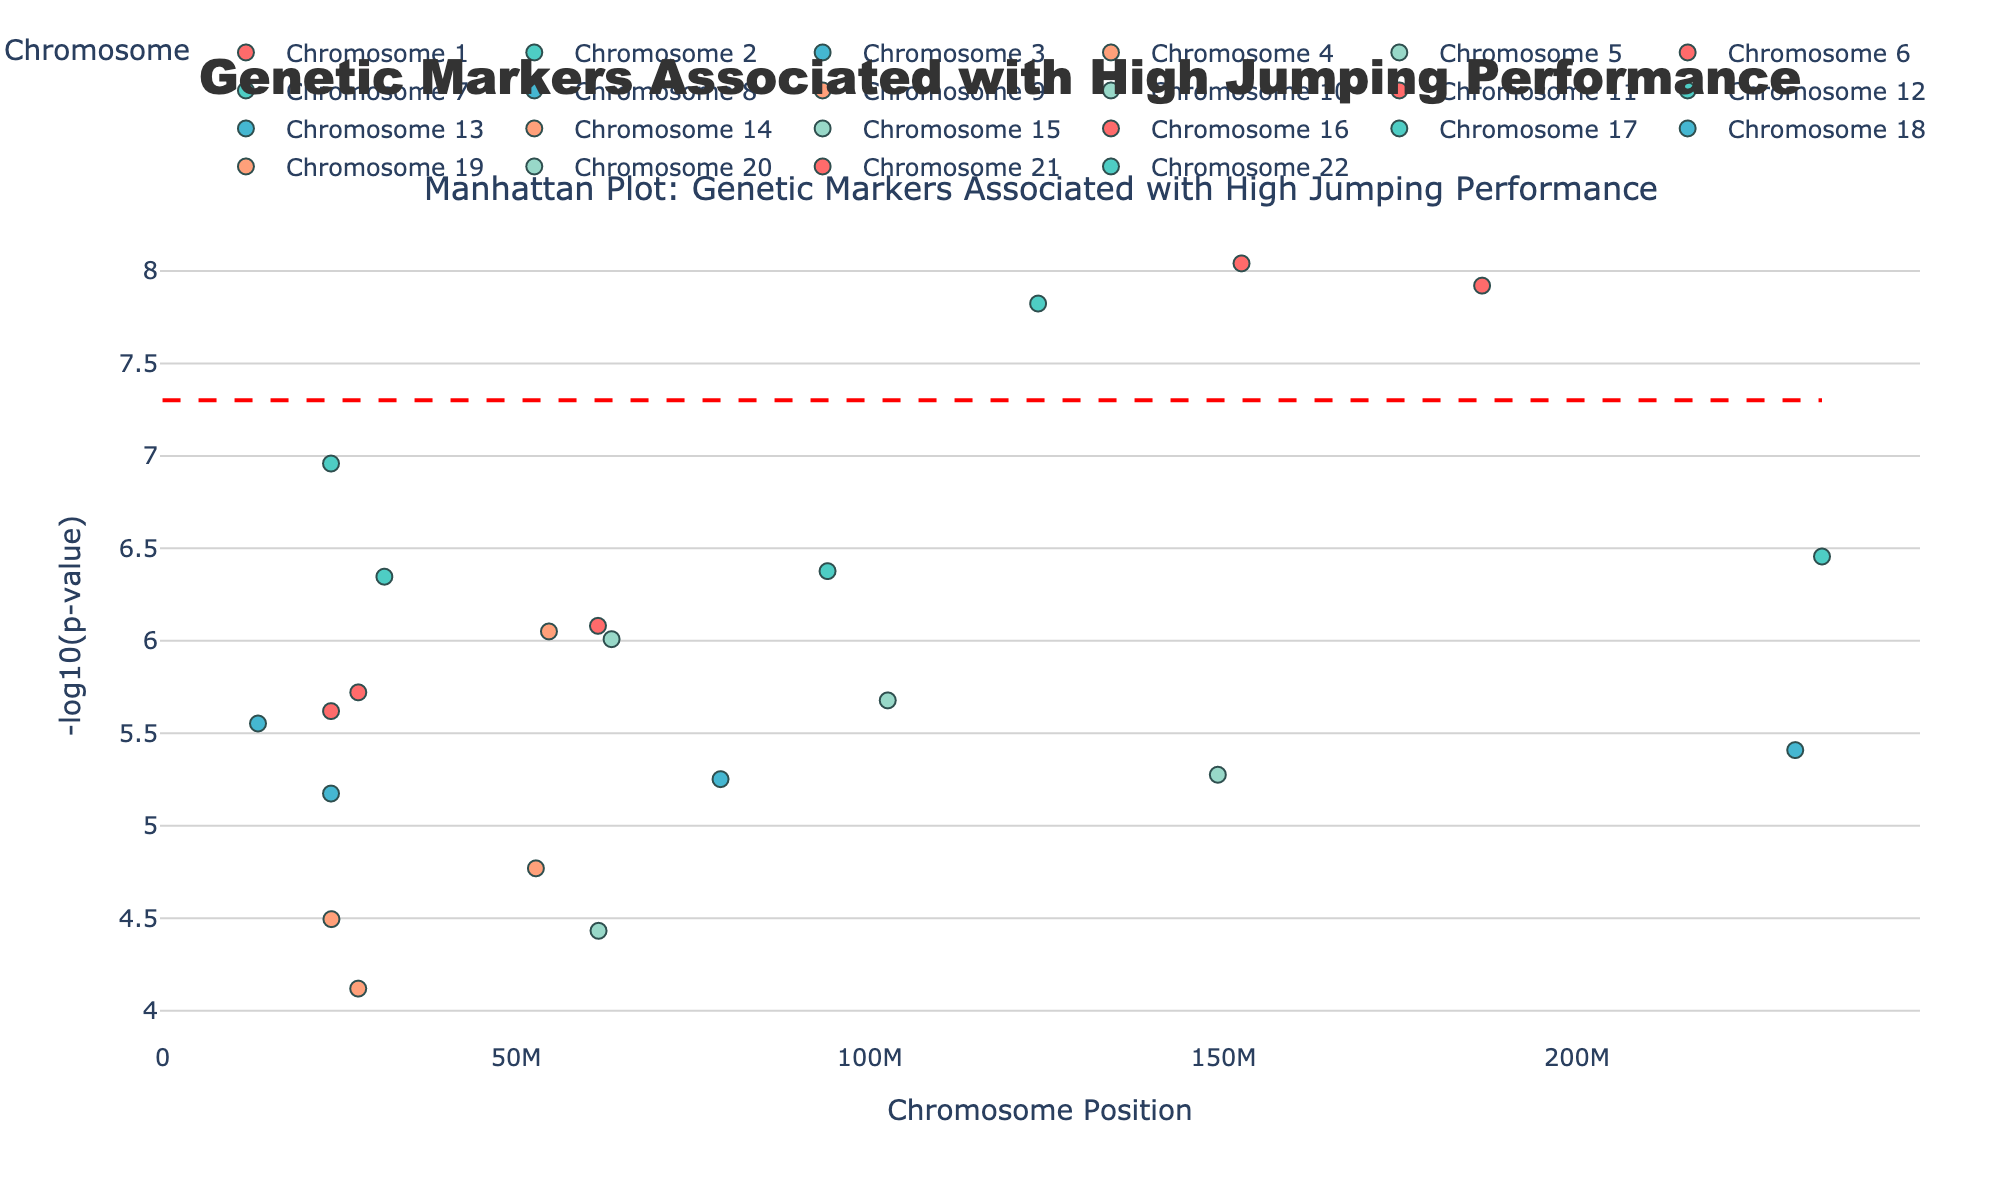What's the title of the plot? Look at the top of the figure where the title is displayed. The title of the plot, "Genetic Markers Associated with High Jumping Performance," indicates the main focus of the plot.
Answer: Genetic Markers Associated with High Jumping Performance Which chromosome has the most significant SNP? The most significant SNP will have the highest -log10(p-value). Check which chromosome has the highest point on the y-axis.
Answer: Chromosome 6 How many chromosomes have SNP associations above the significance threshold? The significance threshold is indicated by the red dashed line. Count how many chromosomes have SNP points above this line.
Answer: 4 What is the -log10(p-value) for the most significant SNP? Find the highest point on the y-axis and note its y-coordinate value. This corresponds to the -log10(p-value).
Answer: 8.04 Between Chromosome 2 and Chromosome 12, which has higher average -log10(p-value)? Identify the -log10(p-value)s for the SNPs on both chromosomes, calculate the average for each, and compare them.
Answer: Chromosome 12 Which chromosome shows the least significant SNP? The least significant SNP will have the lowest -log10(p-value). Look at the lowest points on the plot's y-axis by comparing among different chromosomes.
Answer: Chromosome 9 Are there any chromosomes without significantly associated SNPs? Significantly associated SNPs are those above the significance threshold. Check if any chromosomes have all points below the red dashed line.
Answer: Yes, Chromosome 9 and Chromosome 20 Which two chromosomes have the SNP with the closest -log10(p-value)? Compare the -log10(p-value)s of SNPs across chromosomes visually or by reference, and find the pair with the closest y-values.
Answer: Chromosome 2 and Chromosome 10 What is the position of the SNP with the lowest p-value on Chromosome 3? Identify the lowest p-value (highest -log10(p)) for SNPs on Chromosome 3 and note its position on the x-axis.
Answer: 13498092 